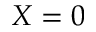<formula> <loc_0><loc_0><loc_500><loc_500>X = 0</formula> 